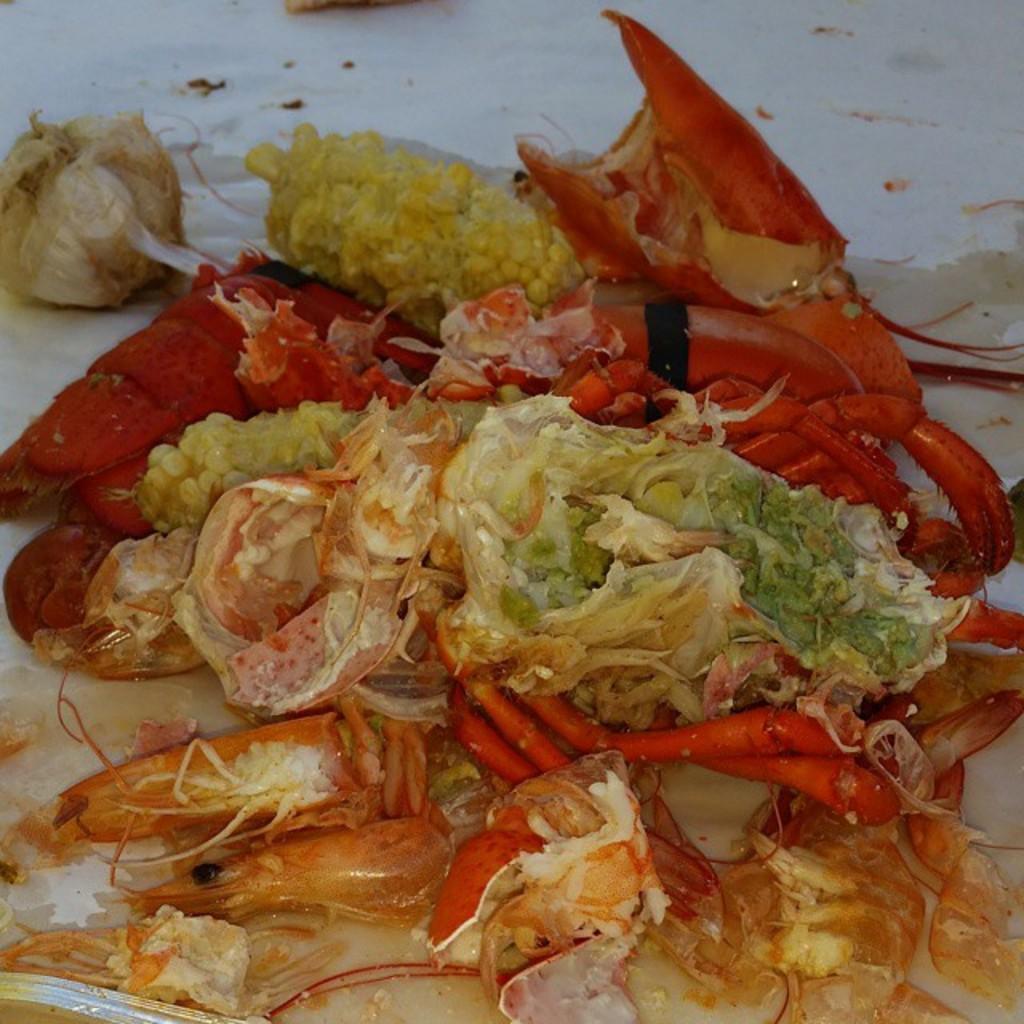Could you give a brief overview of what you see in this image? In this image we can see some food containing a lobster and corn in a plate. 